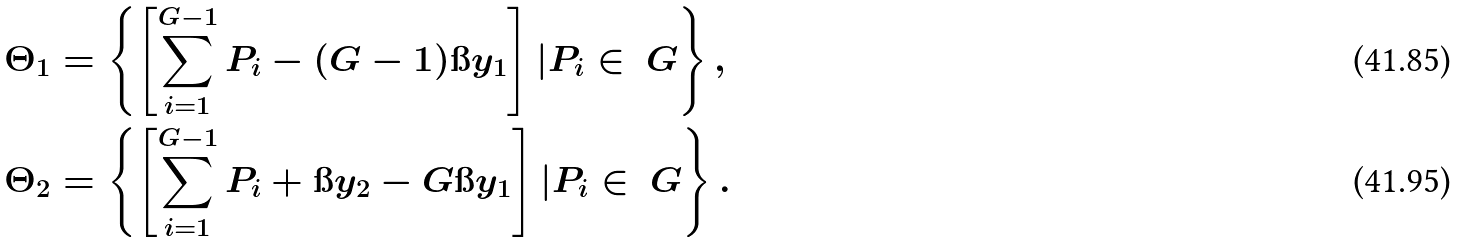<formula> <loc_0><loc_0><loc_500><loc_500>\Theta _ { 1 } & = \left \{ \left [ \sum _ { i = 1 } ^ { G - 1 } P _ { i } - ( G - 1 ) \i y _ { 1 } \right ] | P _ { i } \in \ G \right \} , \\ \Theta _ { 2 } & = \left \{ \left [ \sum _ { i = 1 } ^ { G - 1 } P _ { i } + \i y _ { 2 } - G \i y _ { 1 } \right ] | P _ { i } \in \ G \right \} .</formula> 